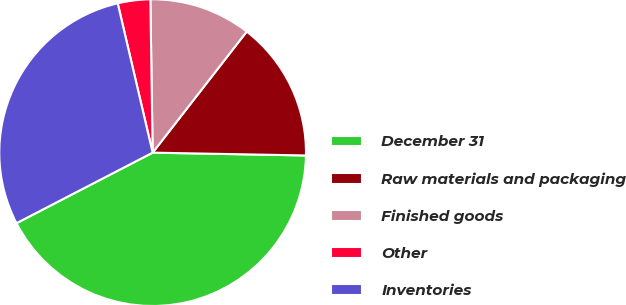Convert chart to OTSL. <chart><loc_0><loc_0><loc_500><loc_500><pie_chart><fcel>December 31<fcel>Raw materials and packaging<fcel>Finished goods<fcel>Other<fcel>Inventories<nl><fcel>42.1%<fcel>14.78%<fcel>10.75%<fcel>3.42%<fcel>28.95%<nl></chart> 